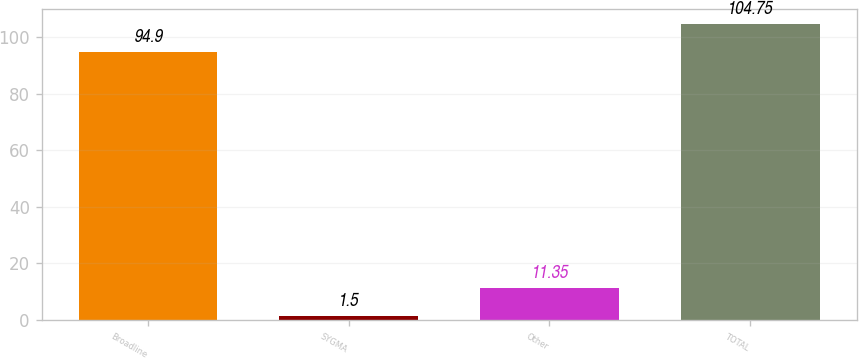<chart> <loc_0><loc_0><loc_500><loc_500><bar_chart><fcel>Broadline<fcel>SYGMA<fcel>Other<fcel>TOTAL<nl><fcel>94.9<fcel>1.5<fcel>11.35<fcel>104.75<nl></chart> 